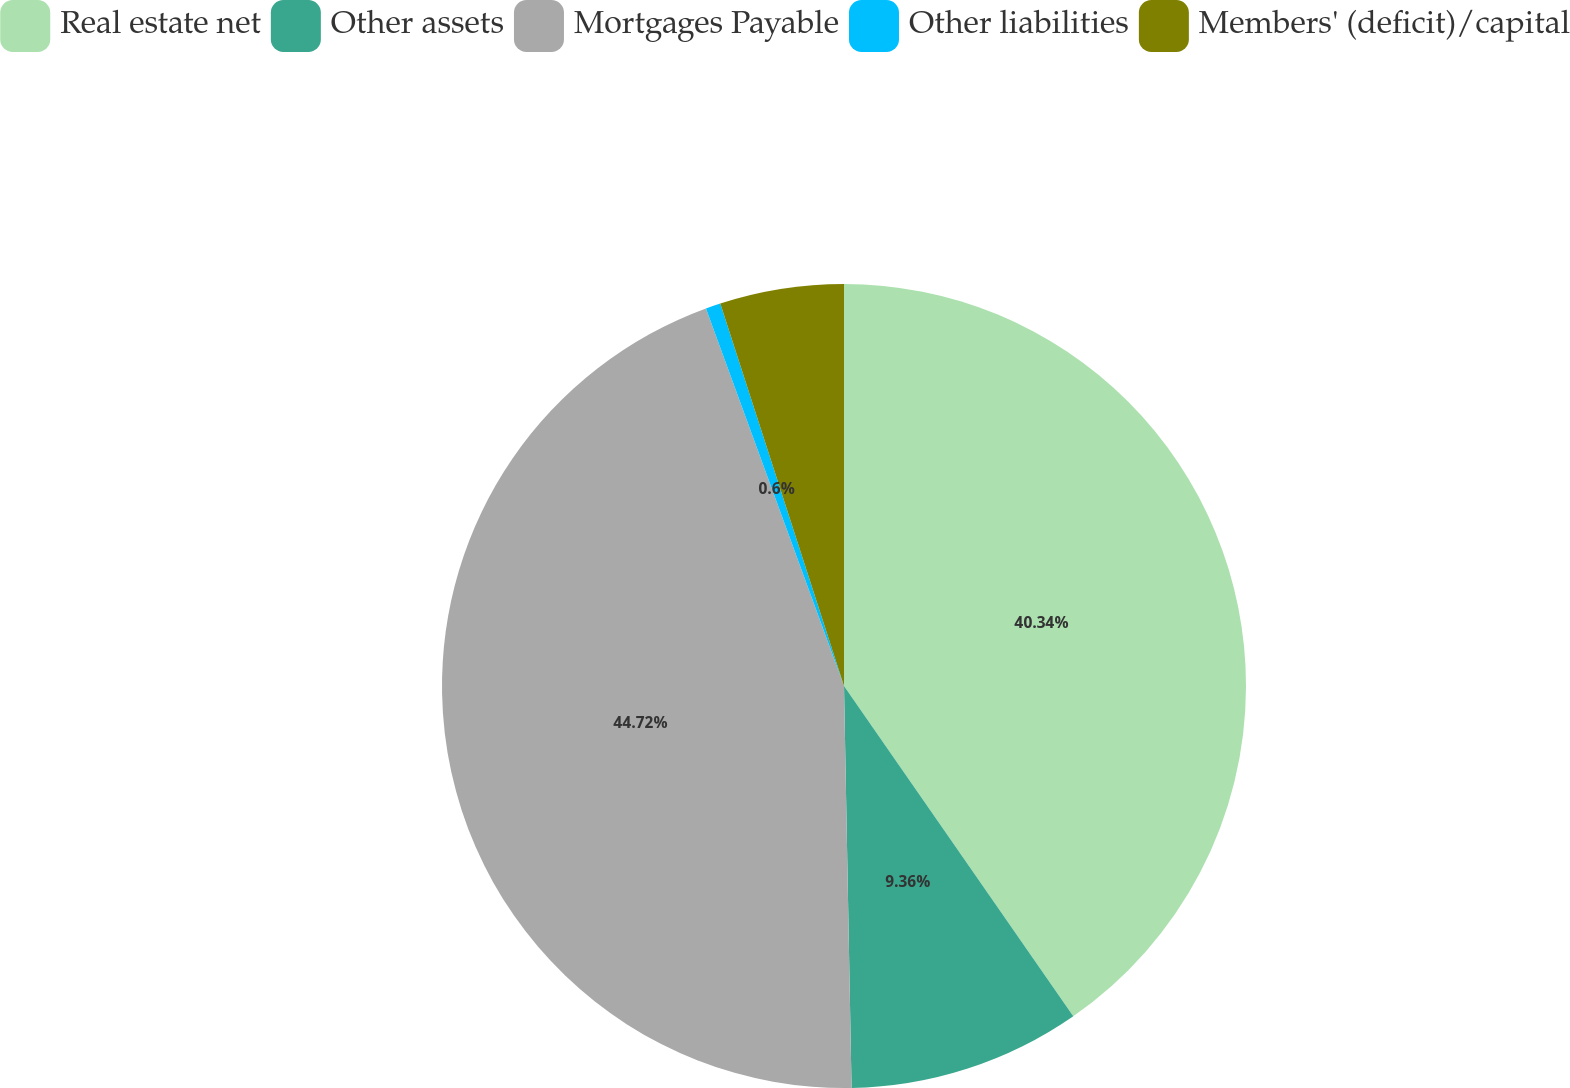Convert chart. <chart><loc_0><loc_0><loc_500><loc_500><pie_chart><fcel>Real estate net<fcel>Other assets<fcel>Mortgages Payable<fcel>Other liabilities<fcel>Members' (deficit)/capital<nl><fcel>40.34%<fcel>9.36%<fcel>44.72%<fcel>0.6%<fcel>4.98%<nl></chart> 